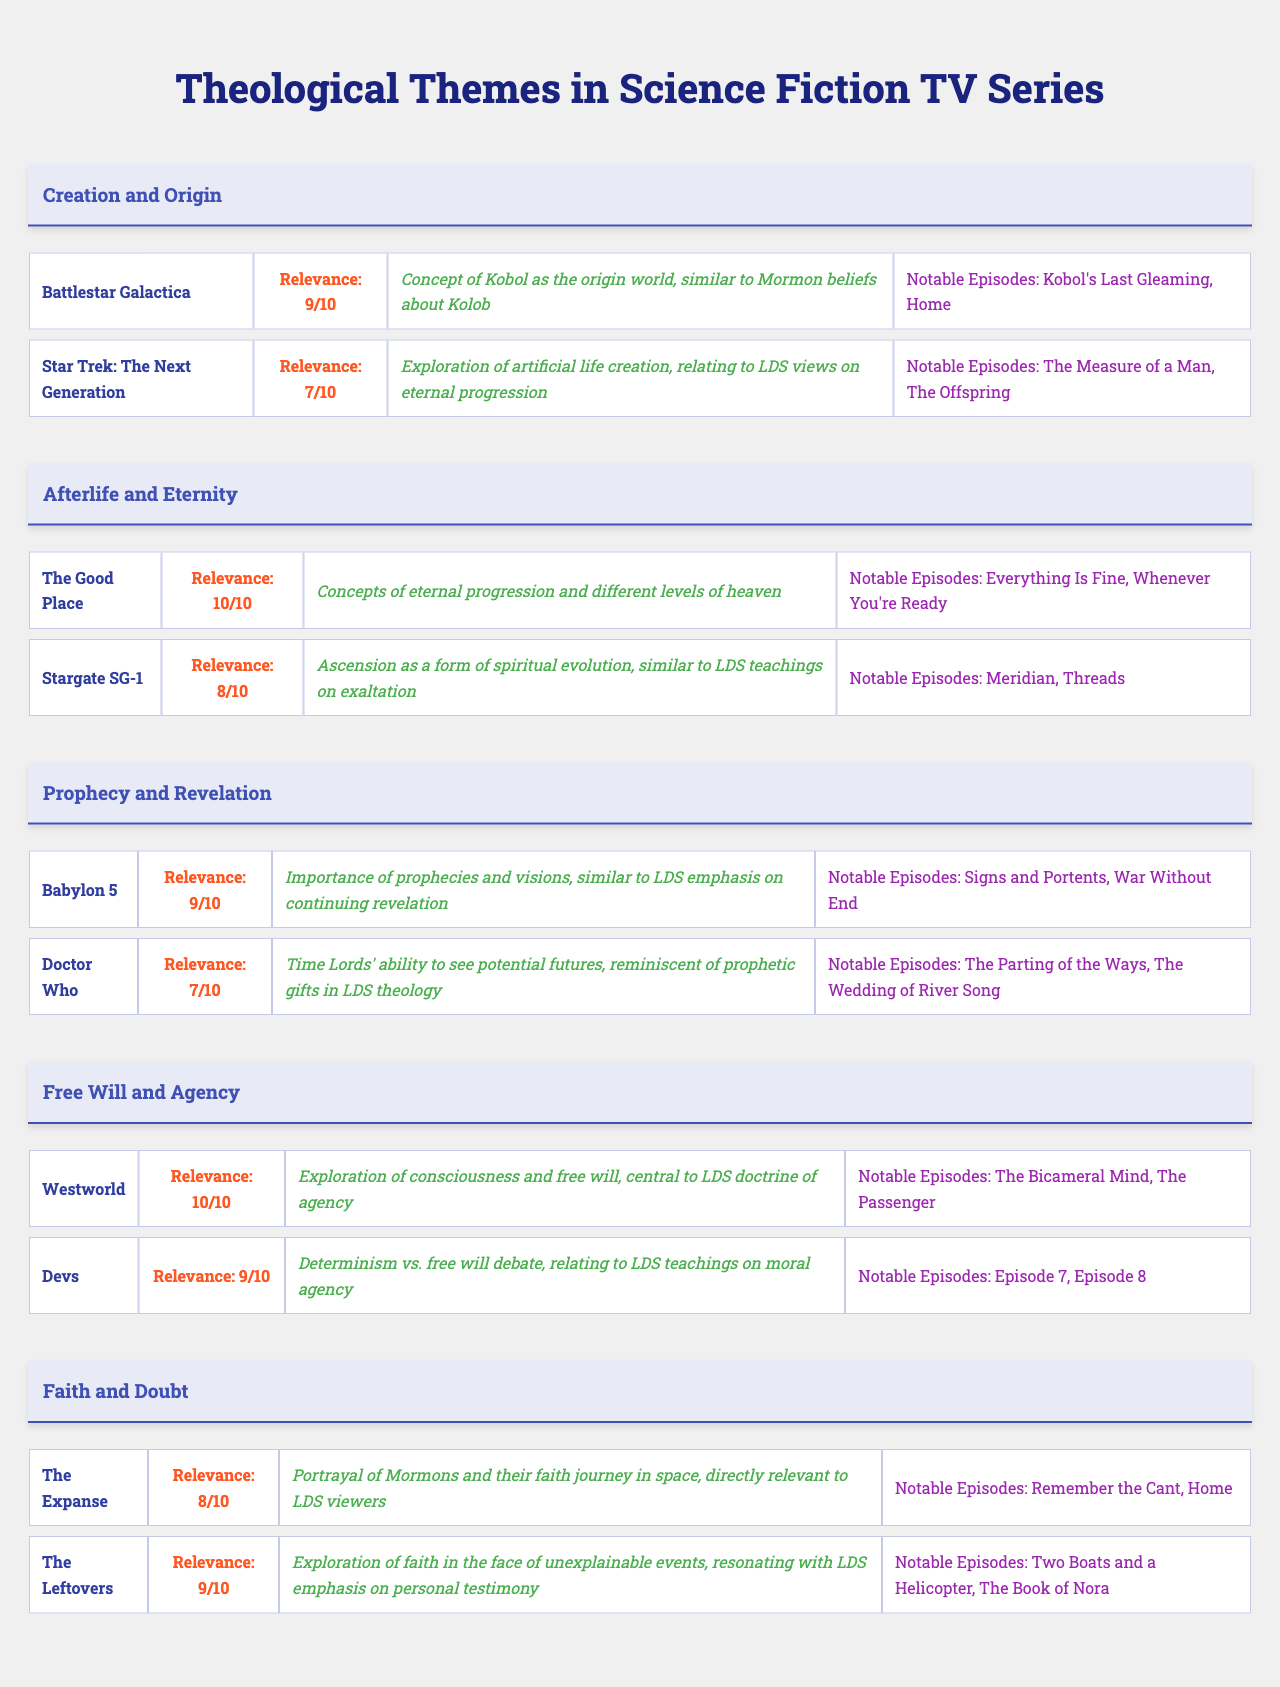What is the theme associated with "Battlestar Galactica"? According to the table, "Battlestar Galactica" is listed under the theme "Creation and Origin".
Answer: Creation and Origin Which series has the highest relevance rating? The table indicates that "The Good Place" has the highest relevance rating of 10, which is the maximum score given in the table.
Answer: The Good Place How many notable episodes are listed for "Doctor Who"? The table shows that "Doctor Who" has two notable episodes listed: "The Parting of the Ways" and "The Wedding of River Song". Therefore, it has 2 notable episodes.
Answer: 2 What Mormon connection is noted for "Stargate SG-1"? The table states that the Mormon connection for "Stargate SG-1" is "Ascension as a form of spiritual evolution, similar to LDS teachings on exaltation".
Answer: Ascension as a form of spiritual evolution Which themes include series that talk about free will? The theme "Free Will and Agency" includes both "Westworld" and "Devs", which are specifically discussing free will and moral agency.
Answer: Free Will and Agency What is the average relevance rating of the series listed under the theme "Faith and Doubt"? The relevance ratings for the series under "Faith and Doubt" are 8 (The Expanse) and 9 (The Leftovers). Summing them gives 17, and dividing by 2 results in an average of 8.5.
Answer: 8.5 Is there a theme that explicitly discusses the concept of prophecy? Yes, the table indicates that "Prophecy and Revelation" is a theme, with series like "Babylon 5" and "Doctor Who" included.
Answer: Yes Which series has a relevance rating lower than 8? The table shows that all series listed have a relevance rating of 8 or higher, with the lowest being 8 for both "The Expanse" and "Stargate SG-1".
Answer: None What notable episodes are associated with "The Leftovers"? The table lists "Two Boats and a Helicopter" and "The Book of Nora" as the notable episodes associated with "The Leftovers".
Answer: Two Boats and a Helicopter, The Book of Nora How many series are associated with the "Creation and Origin" theme? The table shows that there are two series associated with the theme "Creation and Origin": "Battlestar Galactica" and "Star Trek: The Next Generation".
Answer: 2 